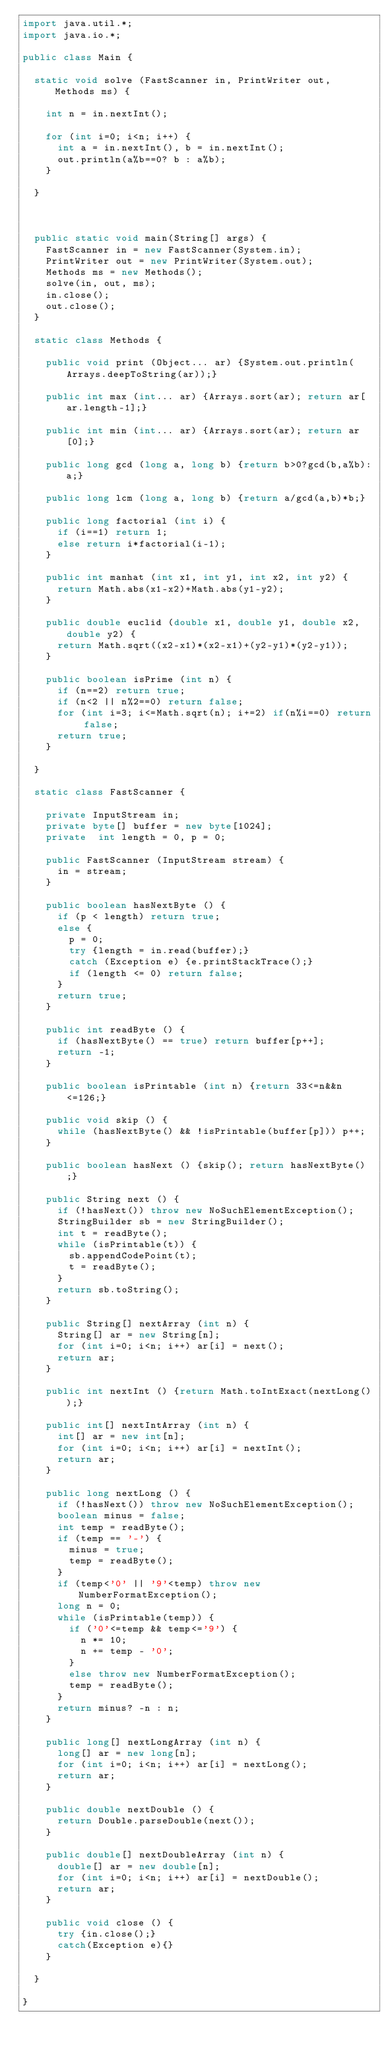Convert code to text. <code><loc_0><loc_0><loc_500><loc_500><_Java_>import java.util.*;
import java.io.*;

public class Main {

	static void solve (FastScanner in, PrintWriter out, Methods ms) {
		
		int n = in.nextInt();
		
		for (int i=0; i<n; i++) {
			int a = in.nextInt(), b = in.nextInt();
			out.println(a%b==0? b : a%b);
		}
		
	}



	public static void main(String[] args) {
		FastScanner in = new FastScanner(System.in);
		PrintWriter out = new PrintWriter(System.out);
		Methods ms = new Methods();
		solve(in, out, ms);
		in.close();
		out.close();
	}

	static class Methods {

		public void print (Object... ar) {System.out.println(Arrays.deepToString(ar));}

		public int max (int... ar) {Arrays.sort(ar); return ar[ar.length-1];}

		public int min (int... ar) {Arrays.sort(ar); return ar[0];}

		public long gcd (long a, long b) {return b>0?gcd(b,a%b):a;}

		public long lcm (long a, long b) {return a/gcd(a,b)*b;}

		public long factorial (int i) {
			if (i==1) return 1;
			else return i*factorial(i-1);
		}

		public int manhat (int x1, int y1, int x2, int y2) {
			return Math.abs(x1-x2)+Math.abs(y1-y2);
		}

		public double euclid (double x1, double y1, double x2, double y2) {
			return Math.sqrt((x2-x1)*(x2-x1)+(y2-y1)*(y2-y1));
		}

		public boolean isPrime (int n) {
			if (n==2) return true;
			if (n<2 || n%2==0) return false;
			for (int i=3; i<=Math.sqrt(n); i+=2) if(n%i==0) return false;
			return true;
		}

	}

	static class FastScanner {

		private InputStream in;
		private byte[] buffer = new byte[1024];
		private  int length = 0, p = 0;

		public FastScanner (InputStream stream) {
			in = stream;
		}

		public boolean hasNextByte () {
			if (p < length) return true;
			else {
				p = 0;
				try {length = in.read(buffer);}
				catch (Exception e) {e.printStackTrace();}
				if (length <= 0) return false;
			}
			return true;
		}

		public int readByte () {
			if (hasNextByte() == true) return buffer[p++];
			return -1;
		}

		public boolean isPrintable (int n) {return 33<=n&&n<=126;}

		public void skip () {
			while (hasNextByte() && !isPrintable(buffer[p])) p++;
		}

		public boolean hasNext () {skip(); return hasNextByte();}

		public String next () {
			if (!hasNext()) throw new NoSuchElementException();
			StringBuilder sb = new StringBuilder();
			int t = readByte();
			while (isPrintable(t)) {
				sb.appendCodePoint(t);
				t = readByte();
			}
			return sb.toString();
		}

		public String[] nextArray (int n) {
			String[] ar = new String[n];
			for (int i=0; i<n; i++) ar[i] = next();
			return ar;
		}

		public int nextInt () {return Math.toIntExact(nextLong());}

		public int[] nextIntArray (int n) {
			int[] ar = new int[n];
			for (int i=0; i<n; i++) ar[i] = nextInt();
			return ar;
		}

		public long nextLong () {
			if (!hasNext()) throw new NoSuchElementException();
			boolean minus = false;
			int temp = readByte();
			if (temp == '-') {
				minus = true;
				temp = readByte();
			}
			if (temp<'0' || '9'<temp) throw new NumberFormatException();
			long n = 0;
			while (isPrintable(temp)) {
				if ('0'<=temp && temp<='9') {
					n *= 10;
					n += temp - '0';
				}
				else throw new NumberFormatException();
				temp = readByte();
			}
			return minus? -n : n;
		}

		public long[] nextLongArray (int n) {
			long[] ar = new long[n];
			for (int i=0; i<n; i++) ar[i] = nextLong();
			return ar;
		}

		public double nextDouble () {
			return Double.parseDouble(next());
		}

		public double[] nextDoubleArray (int n) {
			double[] ar = new double[n];
			for (int i=0; i<n; i++) ar[i] = nextDouble();
			return ar;
		}

		public void close () {
			try {in.close();}
			catch(Exception e){}
		}

	}

}
</code> 